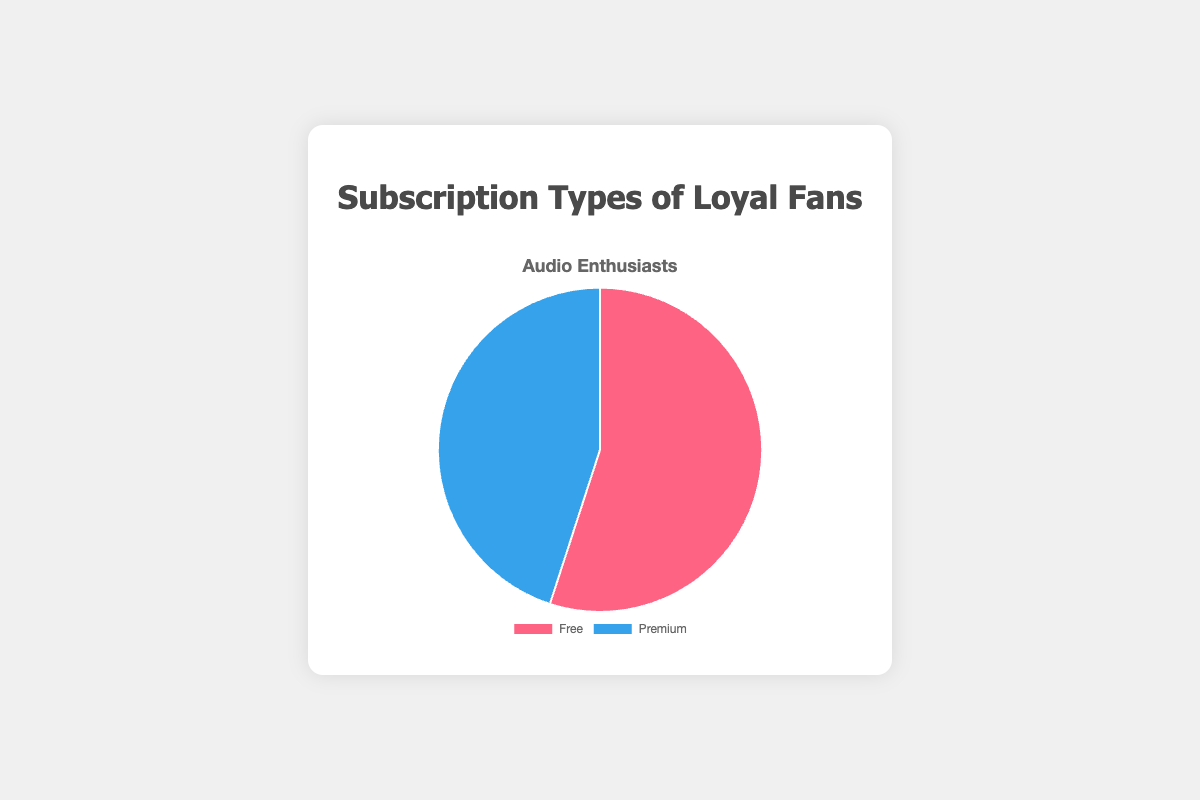Which subscription type has the higher percentage among Audio Enthusiasts? By looking at the pie chart for Audio Enthusiasts, you can see that the 'Free' portion takes up 55% of the chart while the 'Premium' portion takes up 45%. Therefore, 'Free' has the higher percentage.
Answer: Free What is the difference in percentage between Free and Premium subscription types among Audio Enthusiasts? The 'Free' subscription type among Audio Enthusiasts has 55%, and the 'Premium' subscription type has 45%. The difference in percentage is 55 - 45.
Answer: 10% Which category has the largest portion of Premium subscribers? By looking at each category's distribution, you can see that 'Content Creators' have the largest portion of Premium subscribers, at 70%.
Answer: Content Creators Which segment in the pie chart indicates a percentage of 45%? The pie chart has two segments, one for 'Free' and one for 'Premium'. The 'Premium' section makes up 45% of the chart.
Answer: Premium If the Total number of Audio Enthusiasts is 1000, how many of them are Premium subscribers? With 'Premium' subscribers making up 45% of Audio Enthusiasts, you calculate this by taking 45% of 1000, which is 0.45 * 1000.
Answer: 450 If you combine Free and Premium subscription percentages of Audio Enthusiasts, what would the total be? Adding the 'Free' and 'Premium' percentages of Audio Enthusiasts yields 55% + 45%.
Answer: 100% Which color represents the 'Free' subscription type in the pie chart? The 'Free' portion of the pie chart is colored red, as noted in the background color assignment.
Answer: Red How does the percentage of Free subscriptions among Audio Enthusiasts compare to that among Casual Listeners? The 'Free' subscription among Audio Enthusiasts is 55%, while it's 75% among Casual Listeners. The percentage is higher for Casual Listeners.
Answer: Casual Listeners have a higher percentage What percentage of Content Creators opt for Free subscriptions, and how does it compare to Podcasters? 'Free' subscriptions make up 30% for Content Creators and 40% for Podcasters. 40% is greater than 30%.
Answer: Podcasters have a higher percentage Of all the categories provided, which one has the lowest percentage of Premium subscriptions? Casual Listeners have the lowest percentage of Premium subscriptions at 25%.
Answer: Casual Listeners 